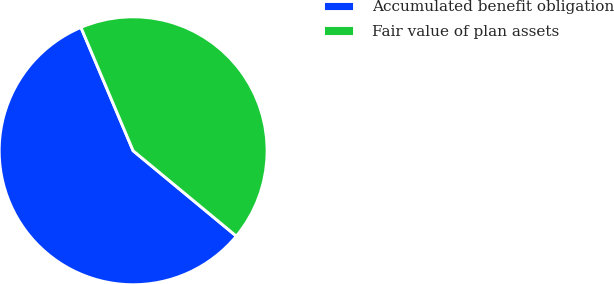Convert chart. <chart><loc_0><loc_0><loc_500><loc_500><pie_chart><fcel>Accumulated benefit obligation<fcel>Fair value of plan assets<nl><fcel>57.63%<fcel>42.37%<nl></chart> 